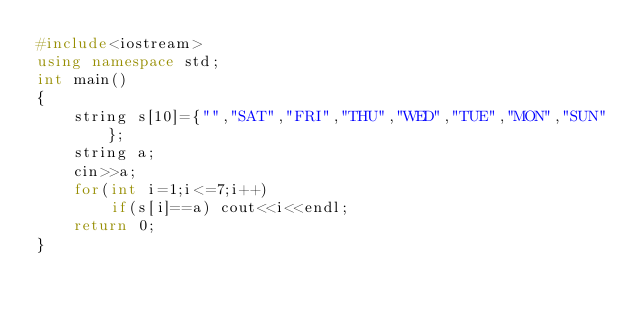<code> <loc_0><loc_0><loc_500><loc_500><_C++_>#include<iostream>
using namespace std;
int main()
{
    string s[10]={"","SAT","FRI","THU","WED","TUE","MON","SUN"};
    string a;
    cin>>a;
    for(int i=1;i<=7;i++)
        if(s[i]==a) cout<<i<<endl;
    return 0;
}
</code> 